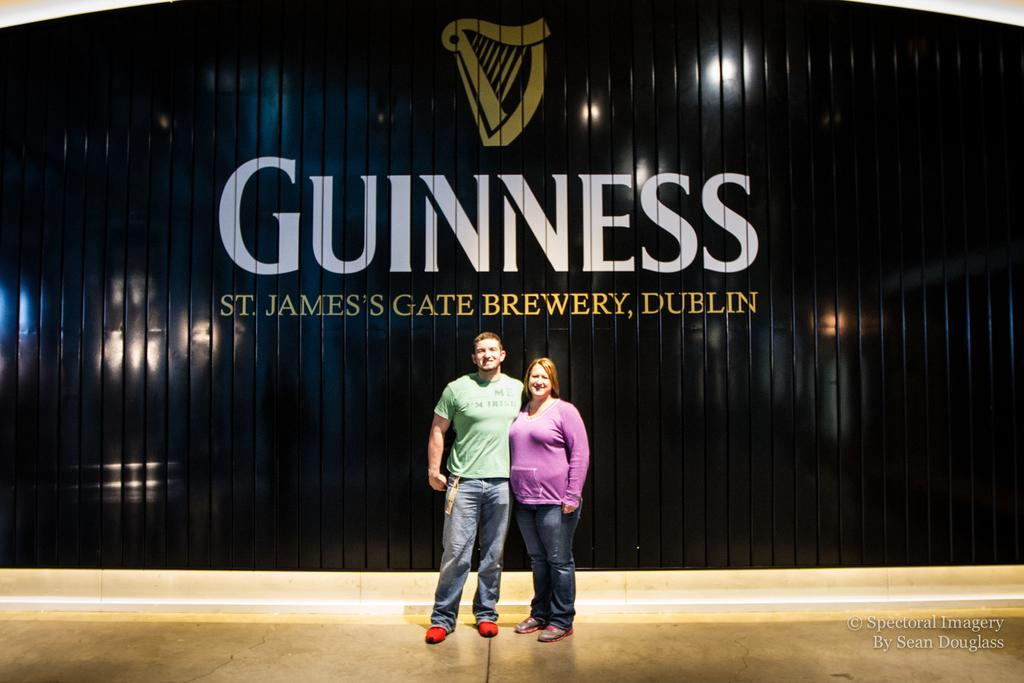How many people are present in the image? There are two people in the image, a man and a woman. What can be seen in the background of the image? There is a wall in the background of the image. What is written on the wall? Something is written on the wall, but the specific text is not mentioned in the facts. What is the logo in the image? The facts do not specify the details of the logo. What is the watermark in the image? The watermark is in the right corner of the image, but its content is not mentioned in the facts. How many sheep are visible in the image? There are no sheep present in the image. What color is the woman's hair in the image? The facts do not mention the color of the woman's hair. 